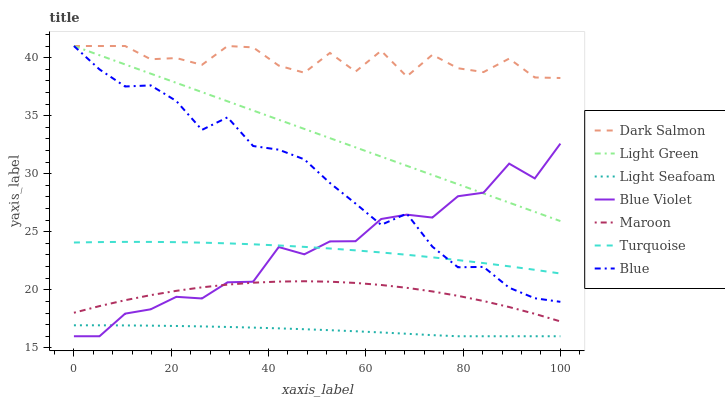Does Light Seafoam have the minimum area under the curve?
Answer yes or no. Yes. Does Dark Salmon have the maximum area under the curve?
Answer yes or no. Yes. Does Turquoise have the minimum area under the curve?
Answer yes or no. No. Does Turquoise have the maximum area under the curve?
Answer yes or no. No. Is Light Green the smoothest?
Answer yes or no. Yes. Is Dark Salmon the roughest?
Answer yes or no. Yes. Is Turquoise the smoothest?
Answer yes or no. No. Is Turquoise the roughest?
Answer yes or no. No. Does Turquoise have the lowest value?
Answer yes or no. No. Does Light Green have the highest value?
Answer yes or no. Yes. Does Turquoise have the highest value?
Answer yes or no. No. Is Light Seafoam less than Maroon?
Answer yes or no. Yes. Is Dark Salmon greater than Light Seafoam?
Answer yes or no. Yes. Does Blue intersect Light Green?
Answer yes or no. Yes. Is Blue less than Light Green?
Answer yes or no. No. Is Blue greater than Light Green?
Answer yes or no. No. Does Light Seafoam intersect Maroon?
Answer yes or no. No. 